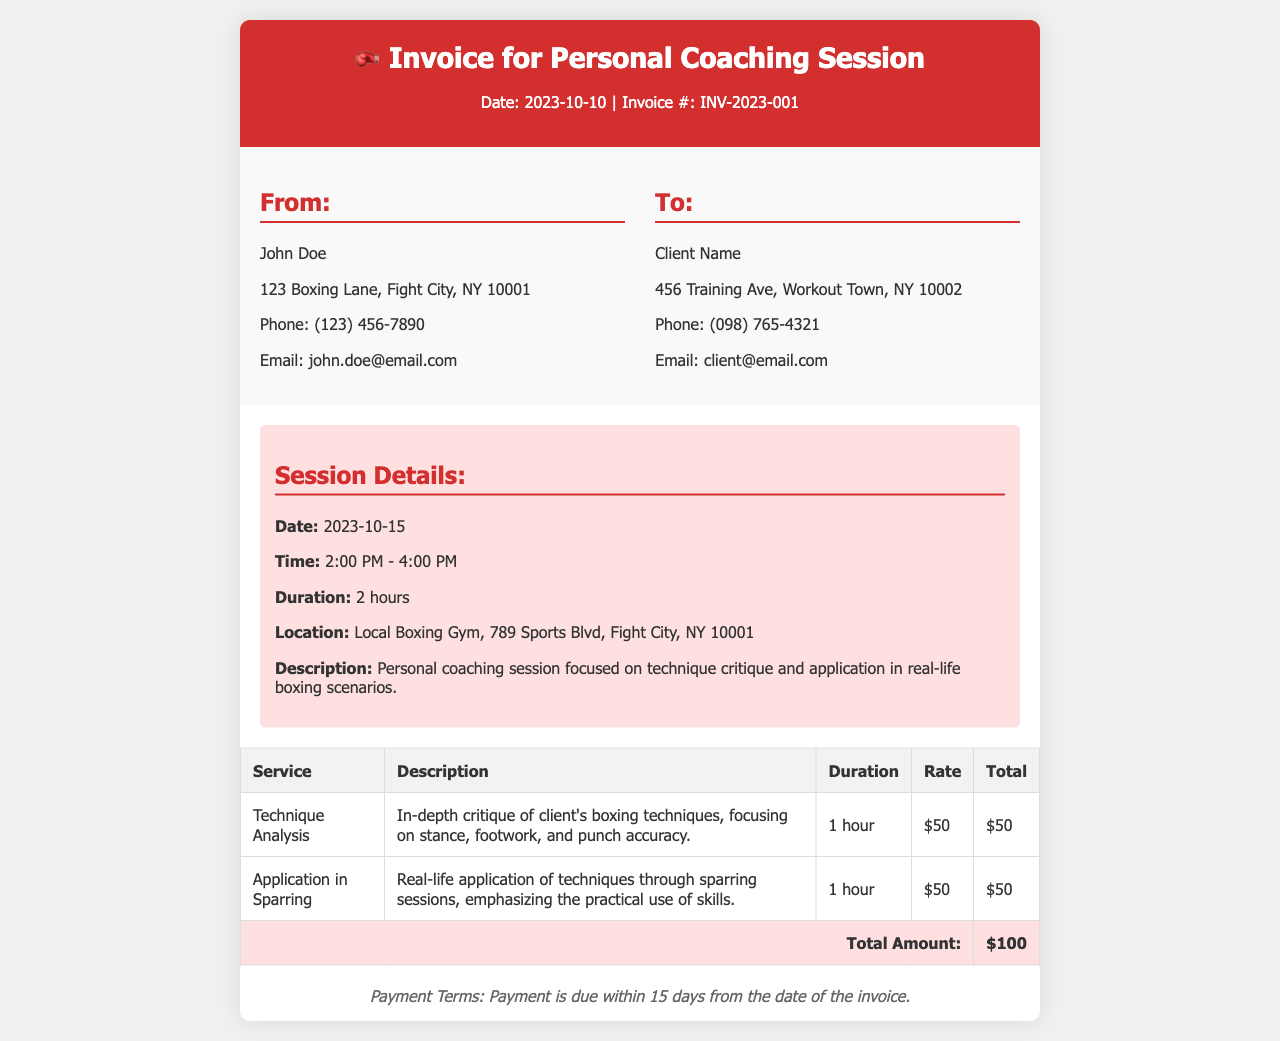what is the invoice date? The invoice date is specified at the top of the document.
Answer: 2023-10-10 who is the service provider? The service provider's name is listed in the 'From' section of the invoice.
Answer: John Doe what is the total amount due? The total amount due is found at the bottom of the services table.
Answer: $100 what is the duration of the session? The duration of the session is mentioned in the session details section.
Answer: 2 hours what service focuses on stance, footwork, and punch accuracy? This service description in the table details a specific service offered.
Answer: Technique Analysis how many hours are allocated for application in sparring? This is specified in the services table under the duration column for that service.
Answer: 1 hour when is the coaching session scheduled? The date of the session is provided in the session details section.
Answer: 2023-10-15 what is the payment term? Payment terms are outlined at the bottom of the invoice.
Answer: Payment is due within 15 days where is the coaching session taking place? The location is described in the session details section.
Answer: Local Boxing Gym, 789 Sports Blvd, Fight City, NY 10001 what is the contact email of the service provider? The contact email can be found in the 'From' section of the invoice.
Answer: john.doe@email.com 